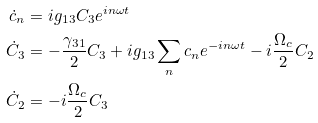<formula> <loc_0><loc_0><loc_500><loc_500>\dot { c } _ { n } & = i g _ { 1 3 } C _ { 3 } e ^ { i n \omega t } \\ \dot { C } _ { 3 } & = - \frac { \gamma _ { 3 1 } } { 2 } C _ { 3 } + i g _ { 1 3 } \sum _ { n } c _ { n } e ^ { - i n \omega t } - i \frac { \Omega _ { c } } { 2 } C _ { 2 } \\ \dot { C } _ { 2 } & = - i \frac { \Omega _ { c } } { 2 } C _ { 3 }</formula> 